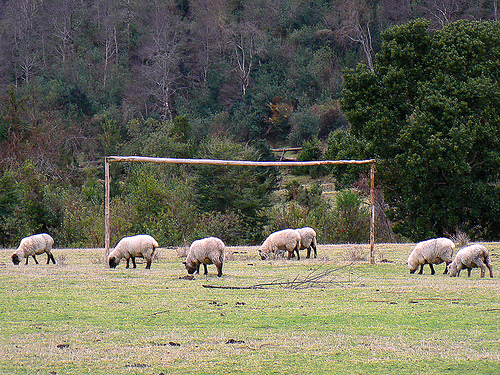<image>
Is there a lamb on the lamb? No. The lamb is not positioned on the lamb. They may be near each other, but the lamb is not supported by or resting on top of the lamb. 